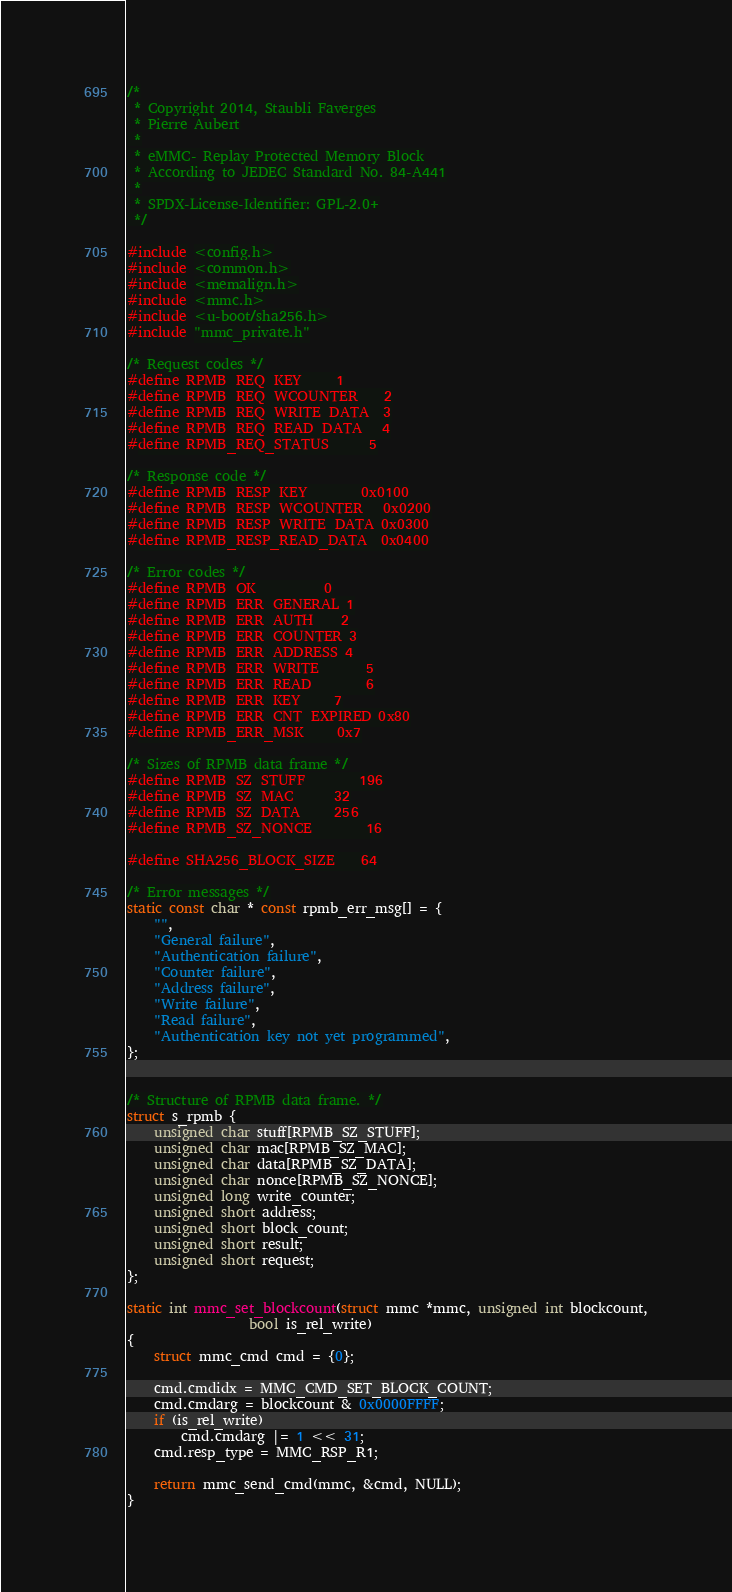Convert code to text. <code><loc_0><loc_0><loc_500><loc_500><_C_>/*
 * Copyright 2014, Staubli Faverges
 * Pierre Aubert
 *
 * eMMC- Replay Protected Memory Block
 * According to JEDEC Standard No. 84-A441
 *
 * SPDX-License-Identifier:	GPL-2.0+
 */

#include <config.h>
#include <common.h>
#include <memalign.h>
#include <mmc.h>
#include <u-boot/sha256.h>
#include "mmc_private.h"

/* Request codes */
#define RPMB_REQ_KEY		1
#define RPMB_REQ_WCOUNTER	2
#define RPMB_REQ_WRITE_DATA	3
#define RPMB_REQ_READ_DATA	4
#define RPMB_REQ_STATUS		5

/* Response code */
#define RPMB_RESP_KEY		0x0100
#define RPMB_RESP_WCOUNTER	0x0200
#define RPMB_RESP_WRITE_DATA	0x0300
#define RPMB_RESP_READ_DATA	0x0400

/* Error codes */
#define RPMB_OK			0
#define RPMB_ERR_GENERAL	1
#define RPMB_ERR_AUTH	2
#define RPMB_ERR_COUNTER	3
#define RPMB_ERR_ADDRESS	4
#define RPMB_ERR_WRITE		5
#define RPMB_ERR_READ		6
#define RPMB_ERR_KEY		7
#define RPMB_ERR_CNT_EXPIRED	0x80
#define RPMB_ERR_MSK		0x7

/* Sizes of RPMB data frame */
#define RPMB_SZ_STUFF		196
#define RPMB_SZ_MAC		32
#define RPMB_SZ_DATA		256
#define RPMB_SZ_NONCE		16

#define SHA256_BLOCK_SIZE	64

/* Error messages */
static const char * const rpmb_err_msg[] = {
	"",
	"General failure",
	"Authentication failure",
	"Counter failure",
	"Address failure",
	"Write failure",
	"Read failure",
	"Authentication key not yet programmed",
};


/* Structure of RPMB data frame. */
struct s_rpmb {
	unsigned char stuff[RPMB_SZ_STUFF];
	unsigned char mac[RPMB_SZ_MAC];
	unsigned char data[RPMB_SZ_DATA];
	unsigned char nonce[RPMB_SZ_NONCE];
	unsigned long write_counter;
	unsigned short address;
	unsigned short block_count;
	unsigned short result;
	unsigned short request;
};

static int mmc_set_blockcount(struct mmc *mmc, unsigned int blockcount,
			      bool is_rel_write)
{
	struct mmc_cmd cmd = {0};

	cmd.cmdidx = MMC_CMD_SET_BLOCK_COUNT;
	cmd.cmdarg = blockcount & 0x0000FFFF;
	if (is_rel_write)
		cmd.cmdarg |= 1 << 31;
	cmd.resp_type = MMC_RSP_R1;

	return mmc_send_cmd(mmc, &cmd, NULL);
}</code> 